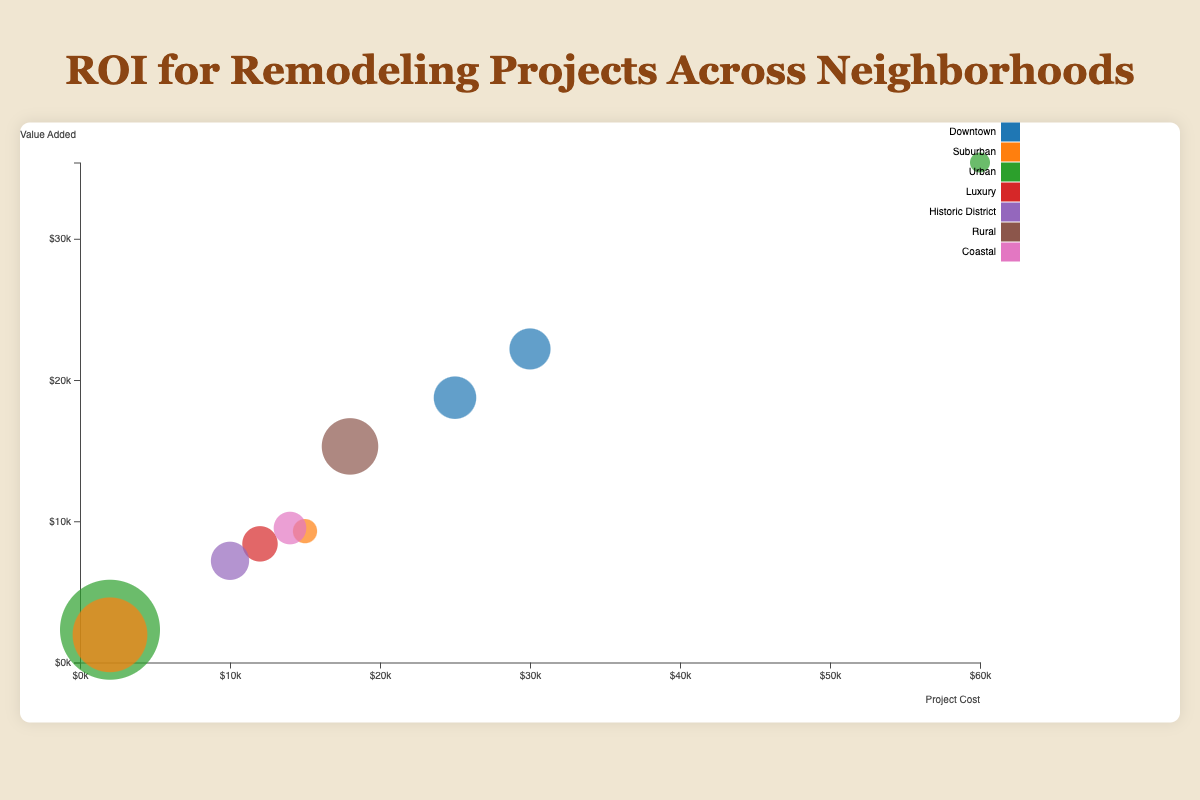Which neighborhood has the highest median ROI for remodeling projects? By observing the size of the bubbles on the chart, we can identify that the largest bubble by ROI is in the Urban neighborhood, associated with the Attic Insulation project.
Answer: Urban What is the median ROI for the Roof Replacement project in Downtown? Locate the bubble corresponding to the Roof Replacement project in Downtown and refer to the displayed ROI value, which is 75%.
Answer: 75% Which project in the Suburban neighborhood has the highest value-added? Examine the bubbles in the Suburban neighborhood and compare their Y-axis values for value added. The Garage Door Replacement project has the highest value added at $1960.
Answer: Garage Door Replacement Is there a correlation between project cost and value added in this dataset? Observing the distribution of bubbles in the chart, there is a general trend where higher project costs often lead to higher value-added, although some lower-cost projects like Attic Insulation also have high value-added.
Answer: Yes, generally positive How many projects have a median ROI greater than 70%? Count the number of bubbles where the size corresponds to an ROI greater than 70%. There are six such projects: Kitchen Remodel, Attic Insulation, Window Replacement, Basement Finish, Roof Replacement, and Garage Door Replacement.
Answer: 6 What's the total cost of remodeling projects in the Downtown neighborhood? Sum the costs of the projects from the Downtown neighborhood: $30000 (Kitchen Remodel) + $25000 (Roof Replacement) = $55000.
Answer: $55000 Which project has the lowest median ROI and what is its value? Locate the smallest bubble to determine the project, which is Major Kitchen Remodel in the Urban neighborhood, with a median ROI of 59%.
Answer: Major Kitchen Remodel, 59% Which neighborhood features the most diverse types of remodeling projects? By examining the legend and the number of different bubbles per neighborhood, Downtown has the highest variety, featuring Kitchen Remodel and Roof Replacement.
Answer: Downtown In which neighborhood does a high ROI not necessarily correlate with high value added? Identify neighborhoods where the ROI is high but the value-added is relatively low. The Urban neighborhood with the Attic Insulation project has a high ROI of 116% but a value-added of only $2320.
Answer: Urban 